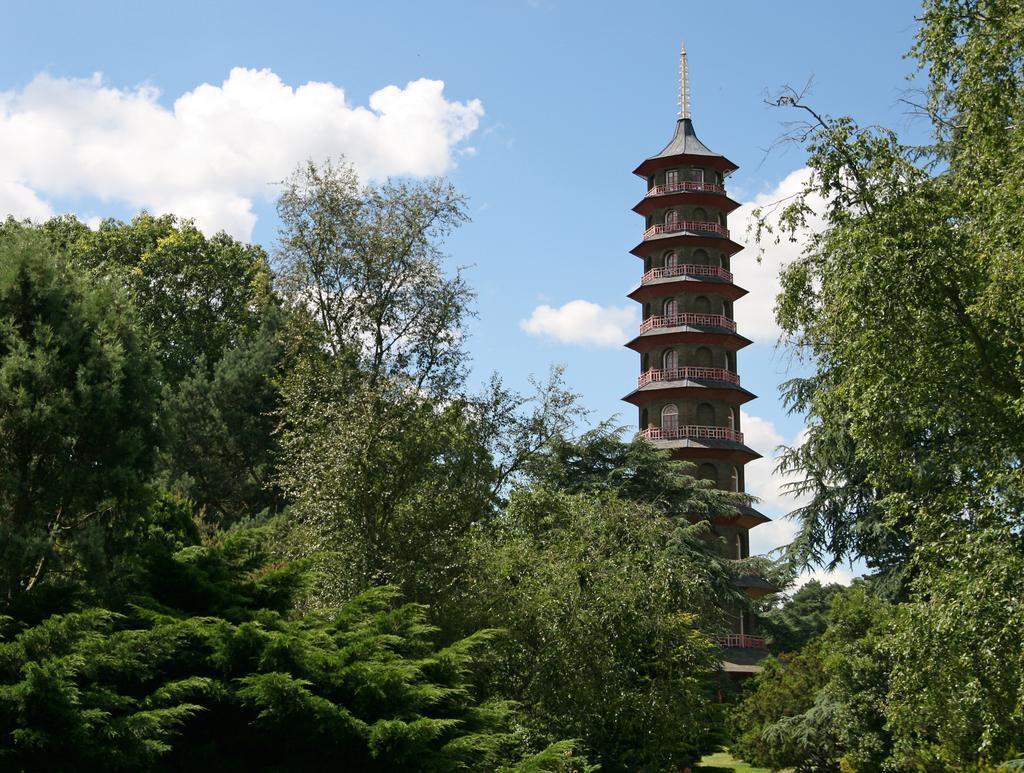In one or two sentences, can you explain what this image depicts? In this image there are trees and there is a tower in the background and the sky is cloudy. 